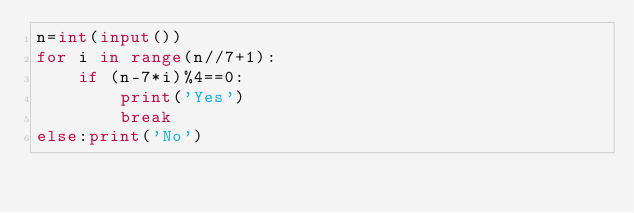Convert code to text. <code><loc_0><loc_0><loc_500><loc_500><_Python_>n=int(input())
for i in range(n//7+1):
    if (n-7*i)%4==0:
        print('Yes')
        break
else:print('No')</code> 